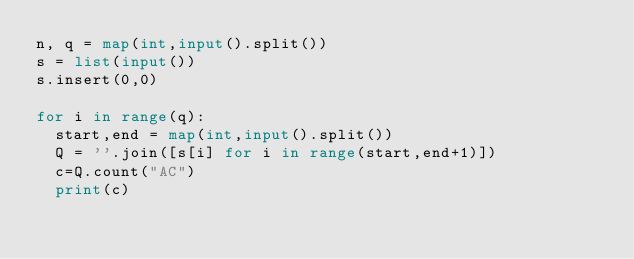Convert code to text. <code><loc_0><loc_0><loc_500><loc_500><_Python_>n, q = map(int,input().split())
s = list(input())
s.insert(0,0)

for i in range(q):
  start,end = map(int,input().split())
  Q = ''.join([s[i] for i in range(start,end+1)])
  c=Q.count("AC")
  print(c) </code> 